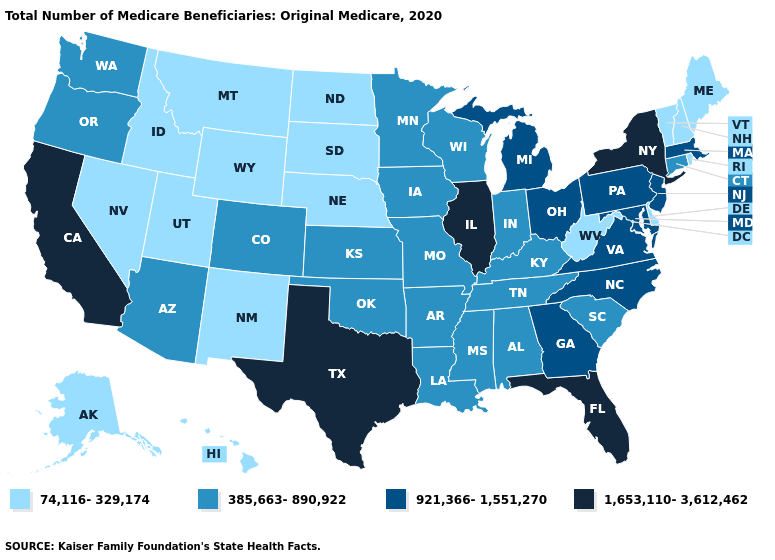Name the states that have a value in the range 385,663-890,922?
Short answer required. Alabama, Arizona, Arkansas, Colorado, Connecticut, Indiana, Iowa, Kansas, Kentucky, Louisiana, Minnesota, Mississippi, Missouri, Oklahoma, Oregon, South Carolina, Tennessee, Washington, Wisconsin. Name the states that have a value in the range 921,366-1,551,270?
Write a very short answer. Georgia, Maryland, Massachusetts, Michigan, New Jersey, North Carolina, Ohio, Pennsylvania, Virginia. Name the states that have a value in the range 74,116-329,174?
Keep it brief. Alaska, Delaware, Hawaii, Idaho, Maine, Montana, Nebraska, Nevada, New Hampshire, New Mexico, North Dakota, Rhode Island, South Dakota, Utah, Vermont, West Virginia, Wyoming. Among the states that border Connecticut , which have the lowest value?
Short answer required. Rhode Island. Which states have the lowest value in the USA?
Quick response, please. Alaska, Delaware, Hawaii, Idaho, Maine, Montana, Nebraska, Nevada, New Hampshire, New Mexico, North Dakota, Rhode Island, South Dakota, Utah, Vermont, West Virginia, Wyoming. Does Montana have a higher value than Kentucky?
Give a very brief answer. No. Which states have the lowest value in the USA?
Write a very short answer. Alaska, Delaware, Hawaii, Idaho, Maine, Montana, Nebraska, Nevada, New Hampshire, New Mexico, North Dakota, Rhode Island, South Dakota, Utah, Vermont, West Virginia, Wyoming. Name the states that have a value in the range 385,663-890,922?
Quick response, please. Alabama, Arizona, Arkansas, Colorado, Connecticut, Indiana, Iowa, Kansas, Kentucky, Louisiana, Minnesota, Mississippi, Missouri, Oklahoma, Oregon, South Carolina, Tennessee, Washington, Wisconsin. What is the lowest value in the MidWest?
Write a very short answer. 74,116-329,174. What is the lowest value in states that border Maine?
Keep it brief. 74,116-329,174. What is the highest value in states that border Idaho?
Answer briefly. 385,663-890,922. Name the states that have a value in the range 1,653,110-3,612,462?
Quick response, please. California, Florida, Illinois, New York, Texas. Which states have the lowest value in the MidWest?
Keep it brief. Nebraska, North Dakota, South Dakota. What is the highest value in the MidWest ?
Answer briefly. 1,653,110-3,612,462. What is the value of Pennsylvania?
Answer briefly. 921,366-1,551,270. 